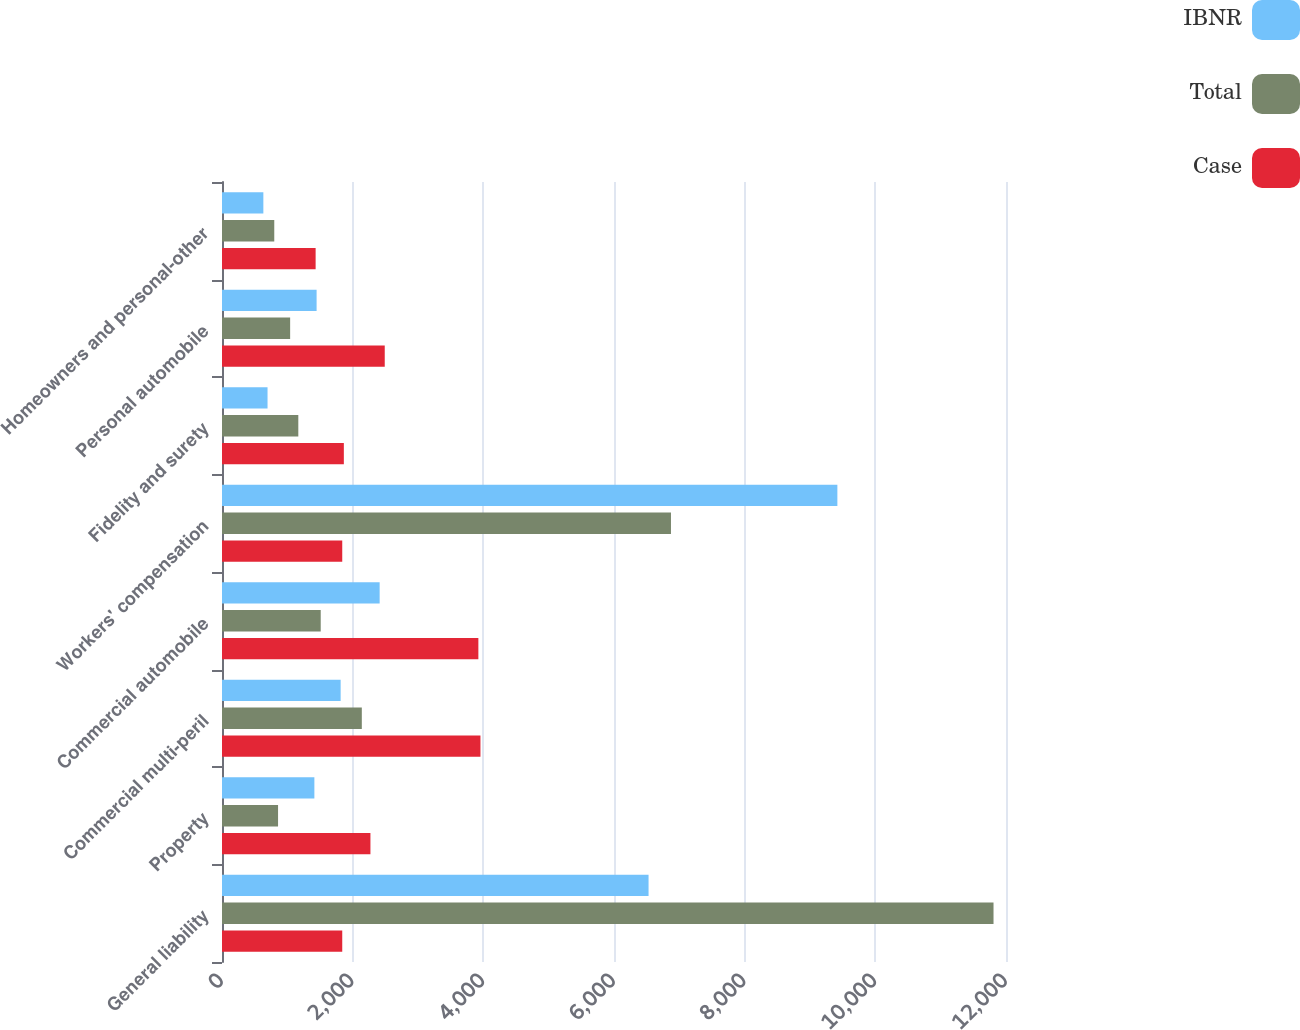<chart> <loc_0><loc_0><loc_500><loc_500><stacked_bar_chart><ecel><fcel>General liability<fcel>Property<fcel>Commercial multi-peril<fcel>Commercial automobile<fcel>Workers' compensation<fcel>Fidelity and surety<fcel>Personal automobile<fcel>Homeowners and personal-other<nl><fcel>IBNR<fcel>6529<fcel>1414<fcel>1816<fcel>2413<fcel>9419<fcel>697<fcel>1448<fcel>633<nl><fcel>Total<fcel>11809<fcel>858<fcel>2140<fcel>1511<fcel>6872<fcel>1168<fcel>1043<fcel>800<nl><fcel>Case<fcel>1840.5<fcel>2272<fcel>3956<fcel>3924<fcel>1840.5<fcel>1865<fcel>2491<fcel>1433<nl></chart> 